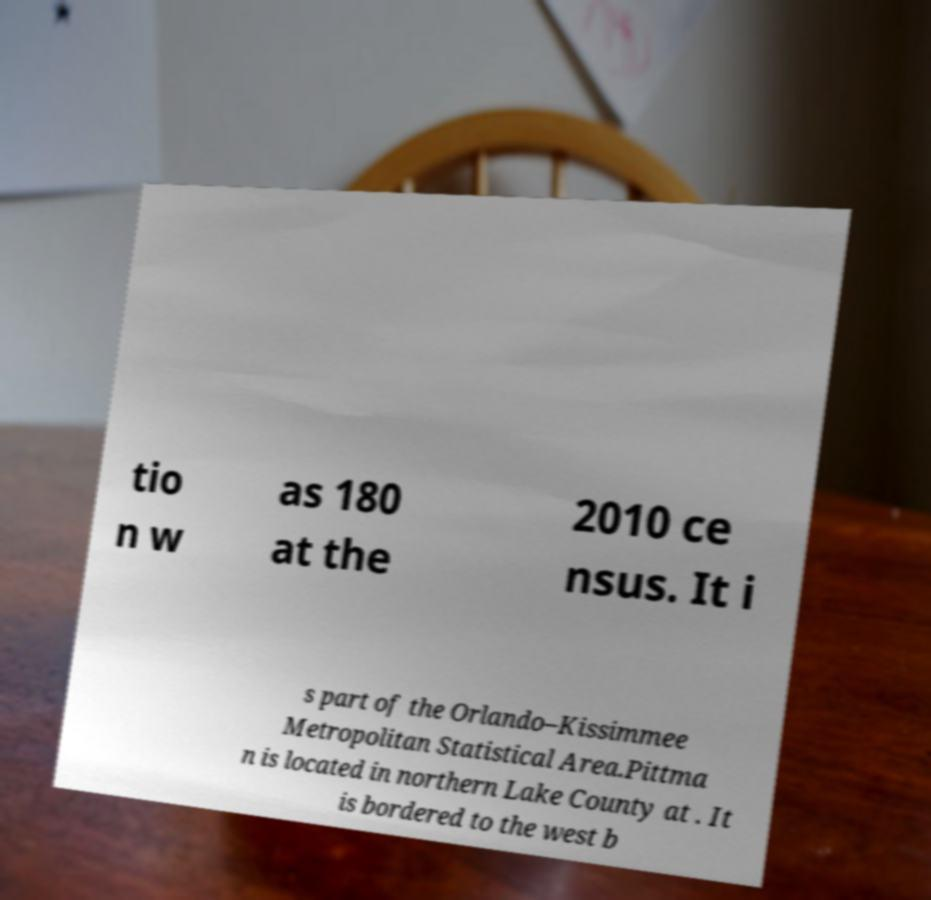There's text embedded in this image that I need extracted. Can you transcribe it verbatim? tio n w as 180 at the 2010 ce nsus. It i s part of the Orlando–Kissimmee Metropolitan Statistical Area.Pittma n is located in northern Lake County at . It is bordered to the west b 